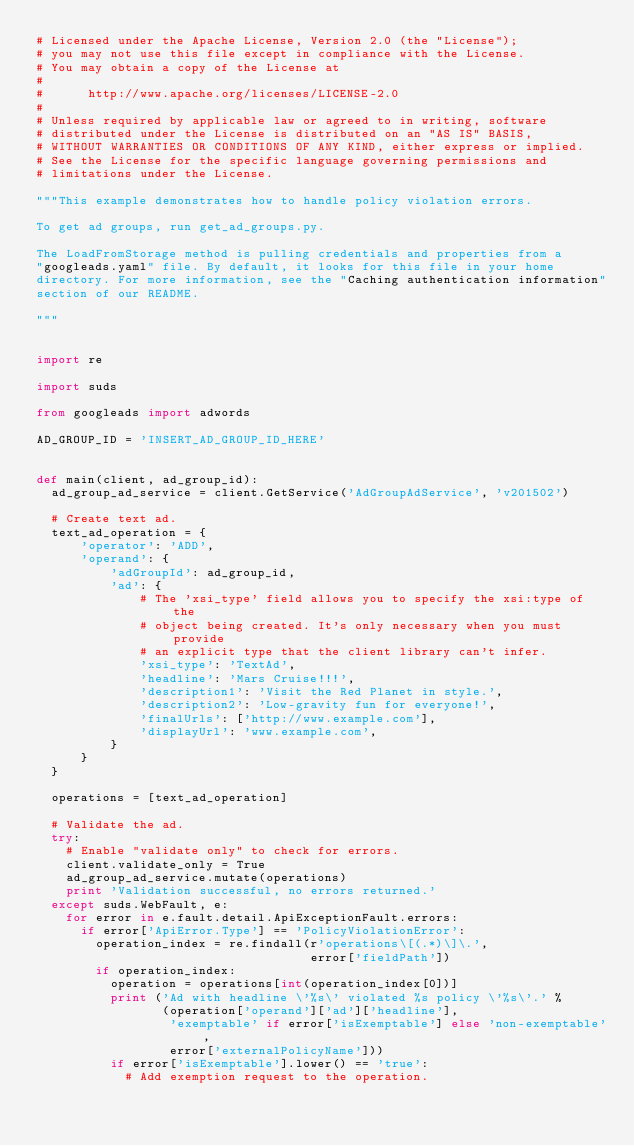<code> <loc_0><loc_0><loc_500><loc_500><_Python_># Licensed under the Apache License, Version 2.0 (the "License");
# you may not use this file except in compliance with the License.
# You may obtain a copy of the License at
#
#      http://www.apache.org/licenses/LICENSE-2.0
#
# Unless required by applicable law or agreed to in writing, software
# distributed under the License is distributed on an "AS IS" BASIS,
# WITHOUT WARRANTIES OR CONDITIONS OF ANY KIND, either express or implied.
# See the License for the specific language governing permissions and
# limitations under the License.

"""This example demonstrates how to handle policy violation errors.

To get ad groups, run get_ad_groups.py.

The LoadFromStorage method is pulling credentials and properties from a
"googleads.yaml" file. By default, it looks for this file in your home
directory. For more information, see the "Caching authentication information"
section of our README.

"""


import re

import suds

from googleads import adwords

AD_GROUP_ID = 'INSERT_AD_GROUP_ID_HERE'


def main(client, ad_group_id):
  ad_group_ad_service = client.GetService('AdGroupAdService', 'v201502')

  # Create text ad.
  text_ad_operation = {
      'operator': 'ADD',
      'operand': {
          'adGroupId': ad_group_id,
          'ad': {
              # The 'xsi_type' field allows you to specify the xsi:type of the
              # object being created. It's only necessary when you must provide
              # an explicit type that the client library can't infer.
              'xsi_type': 'TextAd',
              'headline': 'Mars Cruise!!!',
              'description1': 'Visit the Red Planet in style.',
              'description2': 'Low-gravity fun for everyone!',
              'finalUrls': ['http://www.example.com'],
              'displayUrl': 'www.example.com',
          }
      }
  }

  operations = [text_ad_operation]

  # Validate the ad.
  try:
    # Enable "validate only" to check for errors.
    client.validate_only = True
    ad_group_ad_service.mutate(operations)
    print 'Validation successful, no errors returned.'
  except suds.WebFault, e:
    for error in e.fault.detail.ApiExceptionFault.errors:
      if error['ApiError.Type'] == 'PolicyViolationError':
        operation_index = re.findall(r'operations\[(.*)\]\.',
                                     error['fieldPath'])
        if operation_index:
          operation = operations[int(operation_index[0])]
          print ('Ad with headline \'%s\' violated %s policy \'%s\'.' %
                 (operation['operand']['ad']['headline'],
                  'exemptable' if error['isExemptable'] else 'non-exemptable',
                  error['externalPolicyName']))
          if error['isExemptable'].lower() == 'true':
            # Add exemption request to the operation.</code> 